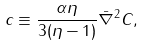<formula> <loc_0><loc_0><loc_500><loc_500>c \equiv \frac { \alpha \eta } { 3 ( \eta - 1 ) } \bar { \nabla } ^ { 2 } C ,</formula> 